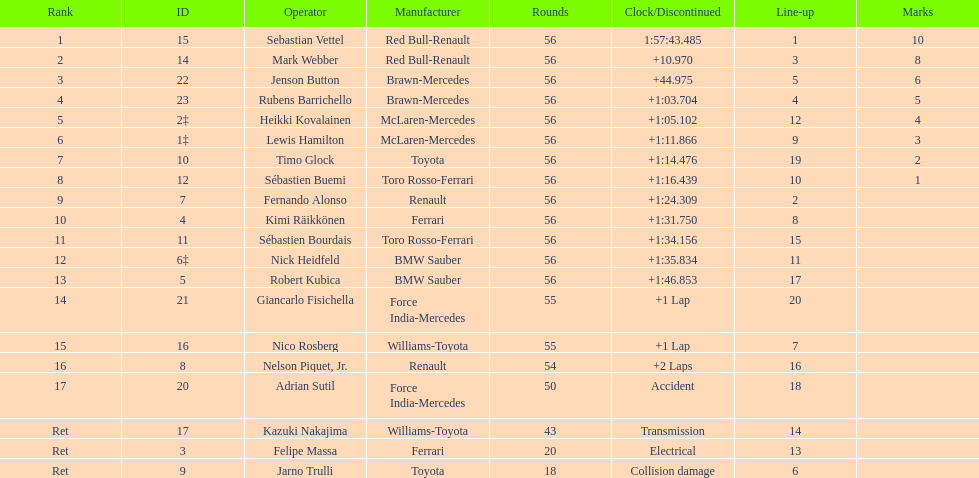Could you parse the entire table as a dict? {'header': ['Rank', 'ID', 'Operator', 'Manufacturer', 'Rounds', 'Clock/Discontinued', 'Line-up', 'Marks'], 'rows': [['1', '15', 'Sebastian Vettel', 'Red Bull-Renault', '56', '1:57:43.485', '1', '10'], ['2', '14', 'Mark Webber', 'Red Bull-Renault', '56', '+10.970', '3', '8'], ['3', '22', 'Jenson Button', 'Brawn-Mercedes', '56', '+44.975', '5', '6'], ['4', '23', 'Rubens Barrichello', 'Brawn-Mercedes', '56', '+1:03.704', '4', '5'], ['5', '2‡', 'Heikki Kovalainen', 'McLaren-Mercedes', '56', '+1:05.102', '12', '4'], ['6', '1‡', 'Lewis Hamilton', 'McLaren-Mercedes', '56', '+1:11.866', '9', '3'], ['7', '10', 'Timo Glock', 'Toyota', '56', '+1:14.476', '19', '2'], ['8', '12', 'Sébastien Buemi', 'Toro Rosso-Ferrari', '56', '+1:16.439', '10', '1'], ['9', '7', 'Fernando Alonso', 'Renault', '56', '+1:24.309', '2', ''], ['10', '4', 'Kimi Räikkönen', 'Ferrari', '56', '+1:31.750', '8', ''], ['11', '11', 'Sébastien Bourdais', 'Toro Rosso-Ferrari', '56', '+1:34.156', '15', ''], ['12', '6‡', 'Nick Heidfeld', 'BMW Sauber', '56', '+1:35.834', '11', ''], ['13', '5', 'Robert Kubica', 'BMW Sauber', '56', '+1:46.853', '17', ''], ['14', '21', 'Giancarlo Fisichella', 'Force India-Mercedes', '55', '+1 Lap', '20', ''], ['15', '16', 'Nico Rosberg', 'Williams-Toyota', '55', '+1 Lap', '7', ''], ['16', '8', 'Nelson Piquet, Jr.', 'Renault', '54', '+2 Laps', '16', ''], ['17', '20', 'Adrian Sutil', 'Force India-Mercedes', '50', 'Accident', '18', ''], ['Ret', '17', 'Kazuki Nakajima', 'Williams-Toyota', '43', 'Transmission', '14', ''], ['Ret', '3', 'Felipe Massa', 'Ferrari', '20', 'Electrical', '13', ''], ['Ret', '9', 'Jarno Trulli', 'Toyota', '18', 'Collision damage', '6', '']]} How many laps in total is the race? 56. 